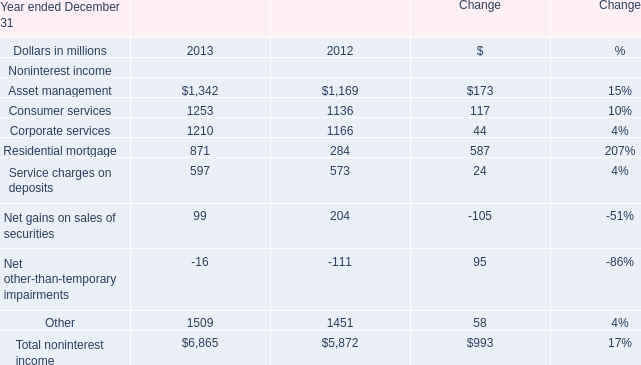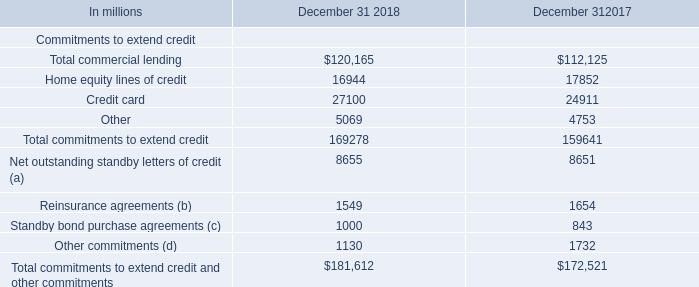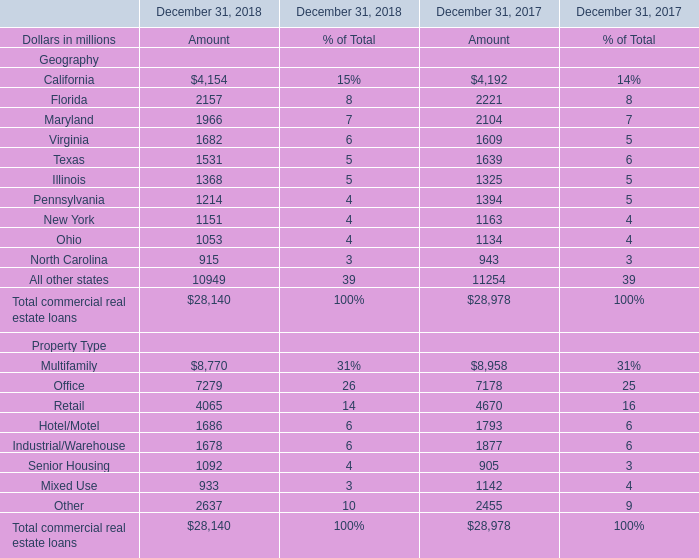What's the sum of Corporate services of Change 2013, and Industrial/Warehouse Property Type of December 31, 2017 Amount ? 
Computations: (1210.0 + 1877.0)
Answer: 3087.0. 